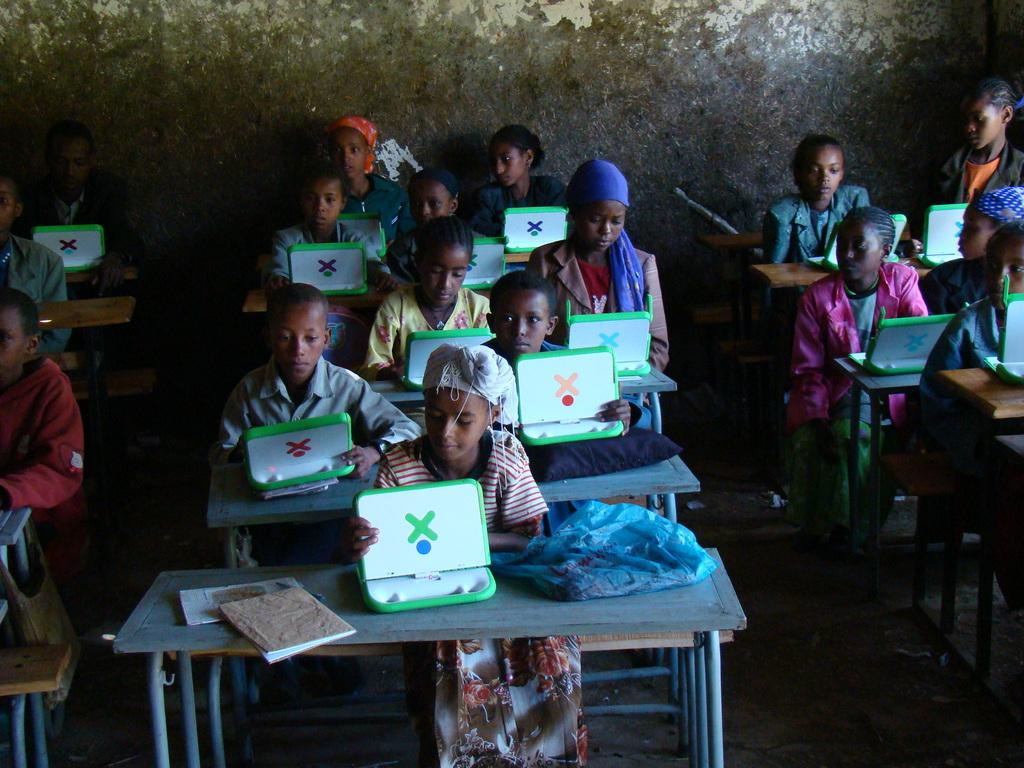What is the main subject of the image? The main subject of the image is a group of kids. What are the kids doing in the image? The kids are sitting on benches in the image. What can be seen in the background of the image? There is a wall in the background of the image. How many passengers are sitting on the benches with the kids in the image? There is no mention of passengers in the image; it only features a group of kids sitting on benches. What is the facial expression of the queen in the image? There is no queen present in the image; it only features a group of kids sitting on benches. 